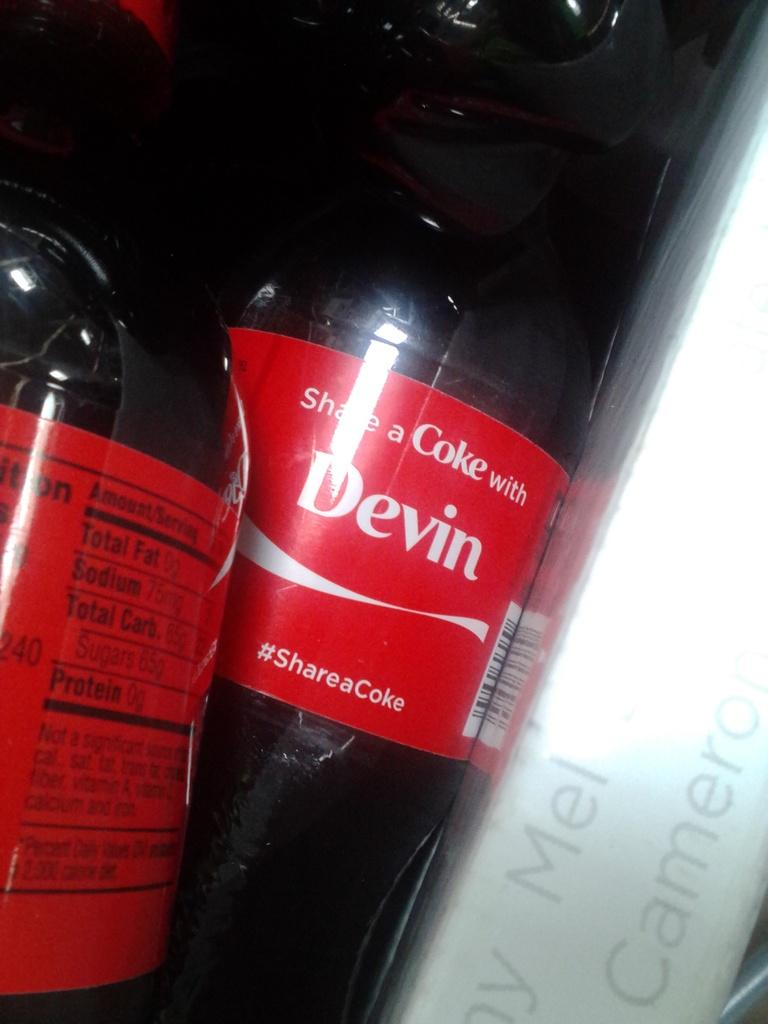<image>
Create a compact narrative representing the image presented. A bottle of Coke has the name Devin printed on the label. 